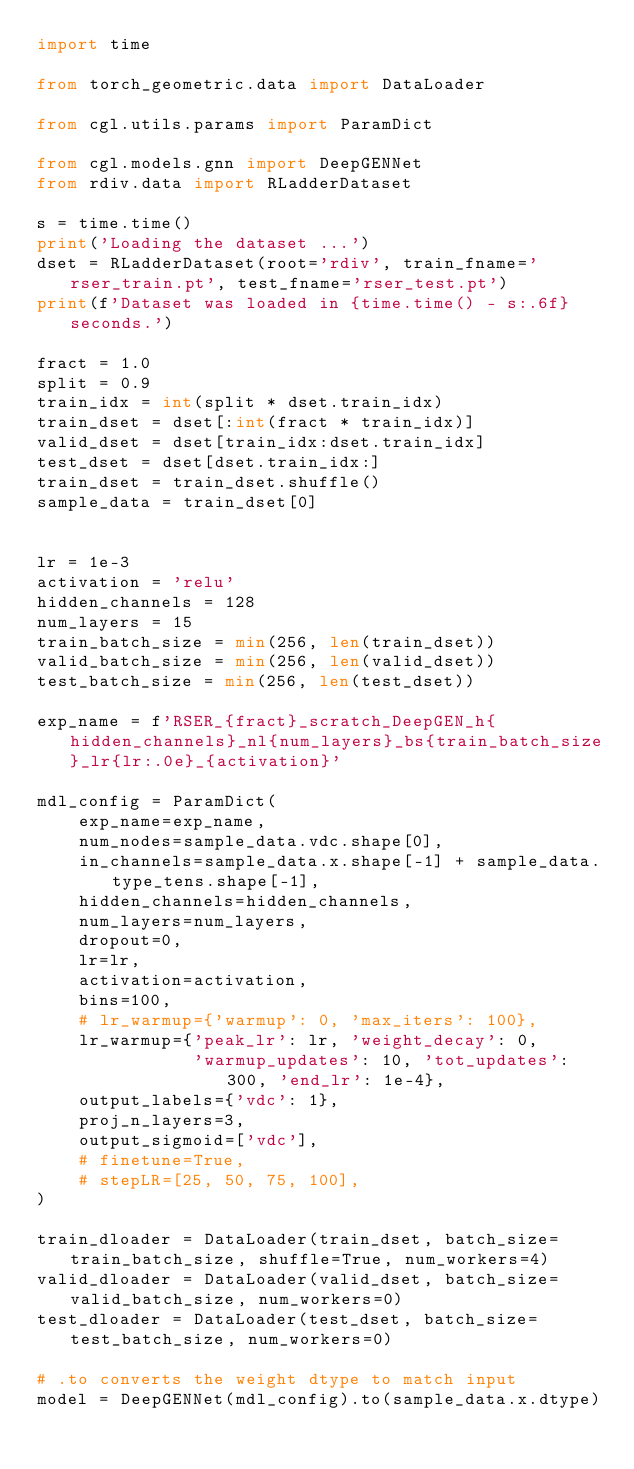Convert code to text. <code><loc_0><loc_0><loc_500><loc_500><_Python_>import time

from torch_geometric.data import DataLoader

from cgl.utils.params import ParamDict

from cgl.models.gnn import DeepGENNet
from rdiv.data import RLadderDataset

s = time.time()
print('Loading the dataset ...')
dset = RLadderDataset(root='rdiv', train_fname='rser_train.pt', test_fname='rser_test.pt')
print(f'Dataset was loaded in {time.time() - s:.6f} seconds.')

fract = 1.0
split = 0.9
train_idx = int(split * dset.train_idx)
train_dset = dset[:int(fract * train_idx)]
valid_dset = dset[train_idx:dset.train_idx]
test_dset = dset[dset.train_idx:]
train_dset = train_dset.shuffle()
sample_data = train_dset[0]


lr = 1e-3
activation = 'relu'
hidden_channels = 128
num_layers = 15
train_batch_size = min(256, len(train_dset))
valid_batch_size = min(256, len(valid_dset)) 
test_batch_size = min(256, len(test_dset)) 

exp_name = f'RSER_{fract}_scratch_DeepGEN_h{hidden_channels}_nl{num_layers}_bs{train_batch_size}_lr{lr:.0e}_{activation}'

mdl_config = ParamDict(
    exp_name=exp_name,
    num_nodes=sample_data.vdc.shape[0],
    in_channels=sample_data.x.shape[-1] + sample_data.type_tens.shape[-1],
    hidden_channels=hidden_channels,
    num_layers=num_layers,
    dropout=0,
    lr=lr,
    activation=activation,
    bins=100,
    # lr_warmup={'warmup': 0, 'max_iters': 100},
    lr_warmup={'peak_lr': lr, 'weight_decay': 0, 
               'warmup_updates': 10, 'tot_updates': 300, 'end_lr': 1e-4},
    output_labels={'vdc': 1},
    proj_n_layers=3,
    output_sigmoid=['vdc'],
    # finetune=True,
    # stepLR=[25, 50, 75, 100],
)

train_dloader = DataLoader(train_dset, batch_size=train_batch_size, shuffle=True, num_workers=4)
valid_dloader = DataLoader(valid_dset, batch_size=valid_batch_size, num_workers=0)
test_dloader = DataLoader(test_dset, batch_size=test_batch_size, num_workers=0)

# .to converts the weight dtype to match input
model = DeepGENNet(mdl_config).to(sample_data.x.dtype)

</code> 